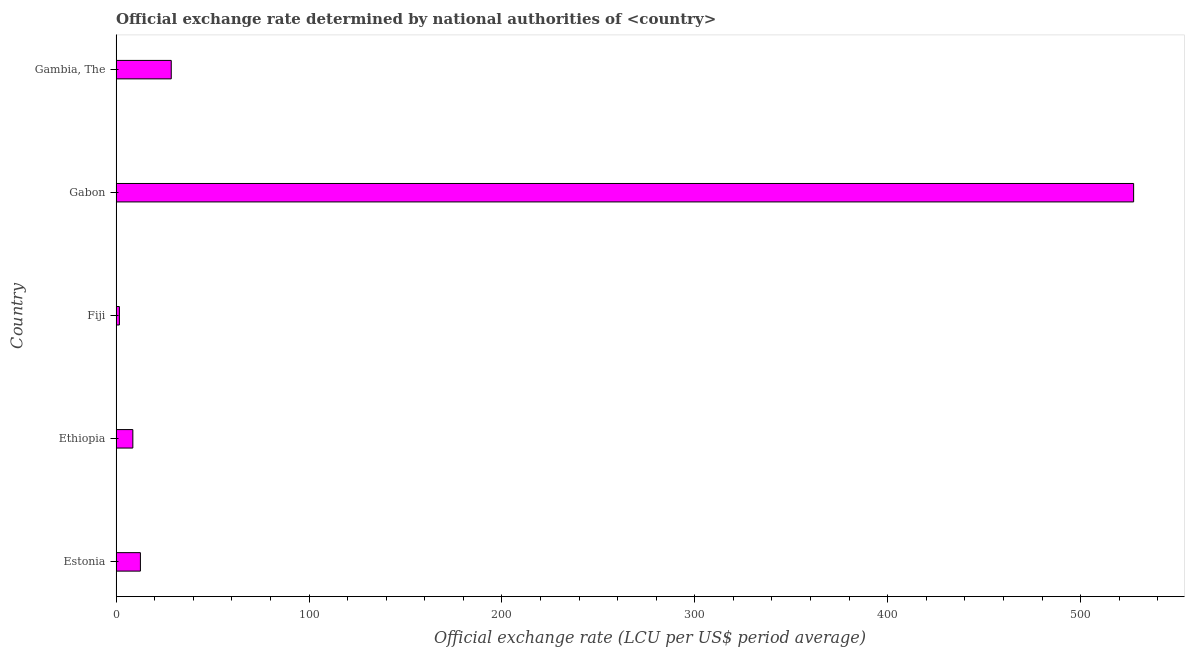Does the graph contain grids?
Offer a terse response. No. What is the title of the graph?
Your answer should be very brief. Official exchange rate determined by national authorities of <country>. What is the label or title of the X-axis?
Provide a succinct answer. Official exchange rate (LCU per US$ period average). What is the official exchange rate in Gambia, The?
Provide a succinct answer. 28.58. Across all countries, what is the maximum official exchange rate?
Offer a terse response. 527.47. Across all countries, what is the minimum official exchange rate?
Your answer should be compact. 1.69. In which country was the official exchange rate maximum?
Your response must be concise. Gabon. In which country was the official exchange rate minimum?
Give a very brief answer. Fiji. What is the sum of the official exchange rate?
Provide a succinct answer. 578.98. What is the difference between the official exchange rate in Gabon and Gambia, The?
Make the answer very short. 498.89. What is the average official exchange rate per country?
Offer a very short reply. 115.8. What is the median official exchange rate?
Offer a very short reply. 12.58. In how many countries, is the official exchange rate greater than 420 ?
Provide a short and direct response. 1. What is the ratio of the official exchange rate in Estonia to that in Fiji?
Ensure brevity in your answer.  7.44. Is the difference between the official exchange rate in Fiji and Gabon greater than the difference between any two countries?
Ensure brevity in your answer.  Yes. What is the difference between the highest and the second highest official exchange rate?
Offer a very short reply. 498.89. Is the sum of the official exchange rate in Gabon and Gambia, The greater than the maximum official exchange rate across all countries?
Provide a short and direct response. Yes. What is the difference between the highest and the lowest official exchange rate?
Offer a very short reply. 525.78. In how many countries, is the official exchange rate greater than the average official exchange rate taken over all countries?
Offer a very short reply. 1. Are all the bars in the graph horizontal?
Make the answer very short. Yes. What is the difference between two consecutive major ticks on the X-axis?
Your answer should be very brief. 100. What is the Official exchange rate (LCU per US$ period average) of Estonia?
Your answer should be compact. 12.58. What is the Official exchange rate (LCU per US$ period average) in Ethiopia?
Your response must be concise. 8.67. What is the Official exchange rate (LCU per US$ period average) in Fiji?
Keep it short and to the point. 1.69. What is the Official exchange rate (LCU per US$ period average) of Gabon?
Give a very brief answer. 527.47. What is the Official exchange rate (LCU per US$ period average) of Gambia, The?
Make the answer very short. 28.58. What is the difference between the Official exchange rate (LCU per US$ period average) in Estonia and Ethiopia?
Offer a terse response. 3.92. What is the difference between the Official exchange rate (LCU per US$ period average) in Estonia and Fiji?
Offer a terse response. 10.89. What is the difference between the Official exchange rate (LCU per US$ period average) in Estonia and Gabon?
Your response must be concise. -514.88. What is the difference between the Official exchange rate (LCU per US$ period average) in Estonia and Gambia, The?
Provide a succinct answer. -15.99. What is the difference between the Official exchange rate (LCU per US$ period average) in Ethiopia and Fiji?
Your answer should be compact. 6.98. What is the difference between the Official exchange rate (LCU per US$ period average) in Ethiopia and Gabon?
Give a very brief answer. -518.8. What is the difference between the Official exchange rate (LCU per US$ period average) in Ethiopia and Gambia, The?
Your response must be concise. -19.91. What is the difference between the Official exchange rate (LCU per US$ period average) in Fiji and Gabon?
Make the answer very short. -525.78. What is the difference between the Official exchange rate (LCU per US$ period average) in Fiji and Gambia, The?
Make the answer very short. -26.88. What is the difference between the Official exchange rate (LCU per US$ period average) in Gabon and Gambia, The?
Provide a short and direct response. 498.89. What is the ratio of the Official exchange rate (LCU per US$ period average) in Estonia to that in Ethiopia?
Ensure brevity in your answer.  1.45. What is the ratio of the Official exchange rate (LCU per US$ period average) in Estonia to that in Fiji?
Ensure brevity in your answer.  7.44. What is the ratio of the Official exchange rate (LCU per US$ period average) in Estonia to that in Gabon?
Give a very brief answer. 0.02. What is the ratio of the Official exchange rate (LCU per US$ period average) in Estonia to that in Gambia, The?
Offer a very short reply. 0.44. What is the ratio of the Official exchange rate (LCU per US$ period average) in Ethiopia to that in Fiji?
Offer a terse response. 5.12. What is the ratio of the Official exchange rate (LCU per US$ period average) in Ethiopia to that in Gabon?
Offer a terse response. 0.02. What is the ratio of the Official exchange rate (LCU per US$ period average) in Ethiopia to that in Gambia, The?
Provide a succinct answer. 0.3. What is the ratio of the Official exchange rate (LCU per US$ period average) in Fiji to that in Gabon?
Offer a very short reply. 0. What is the ratio of the Official exchange rate (LCU per US$ period average) in Fiji to that in Gambia, The?
Give a very brief answer. 0.06. What is the ratio of the Official exchange rate (LCU per US$ period average) in Gabon to that in Gambia, The?
Offer a very short reply. 18.46. 